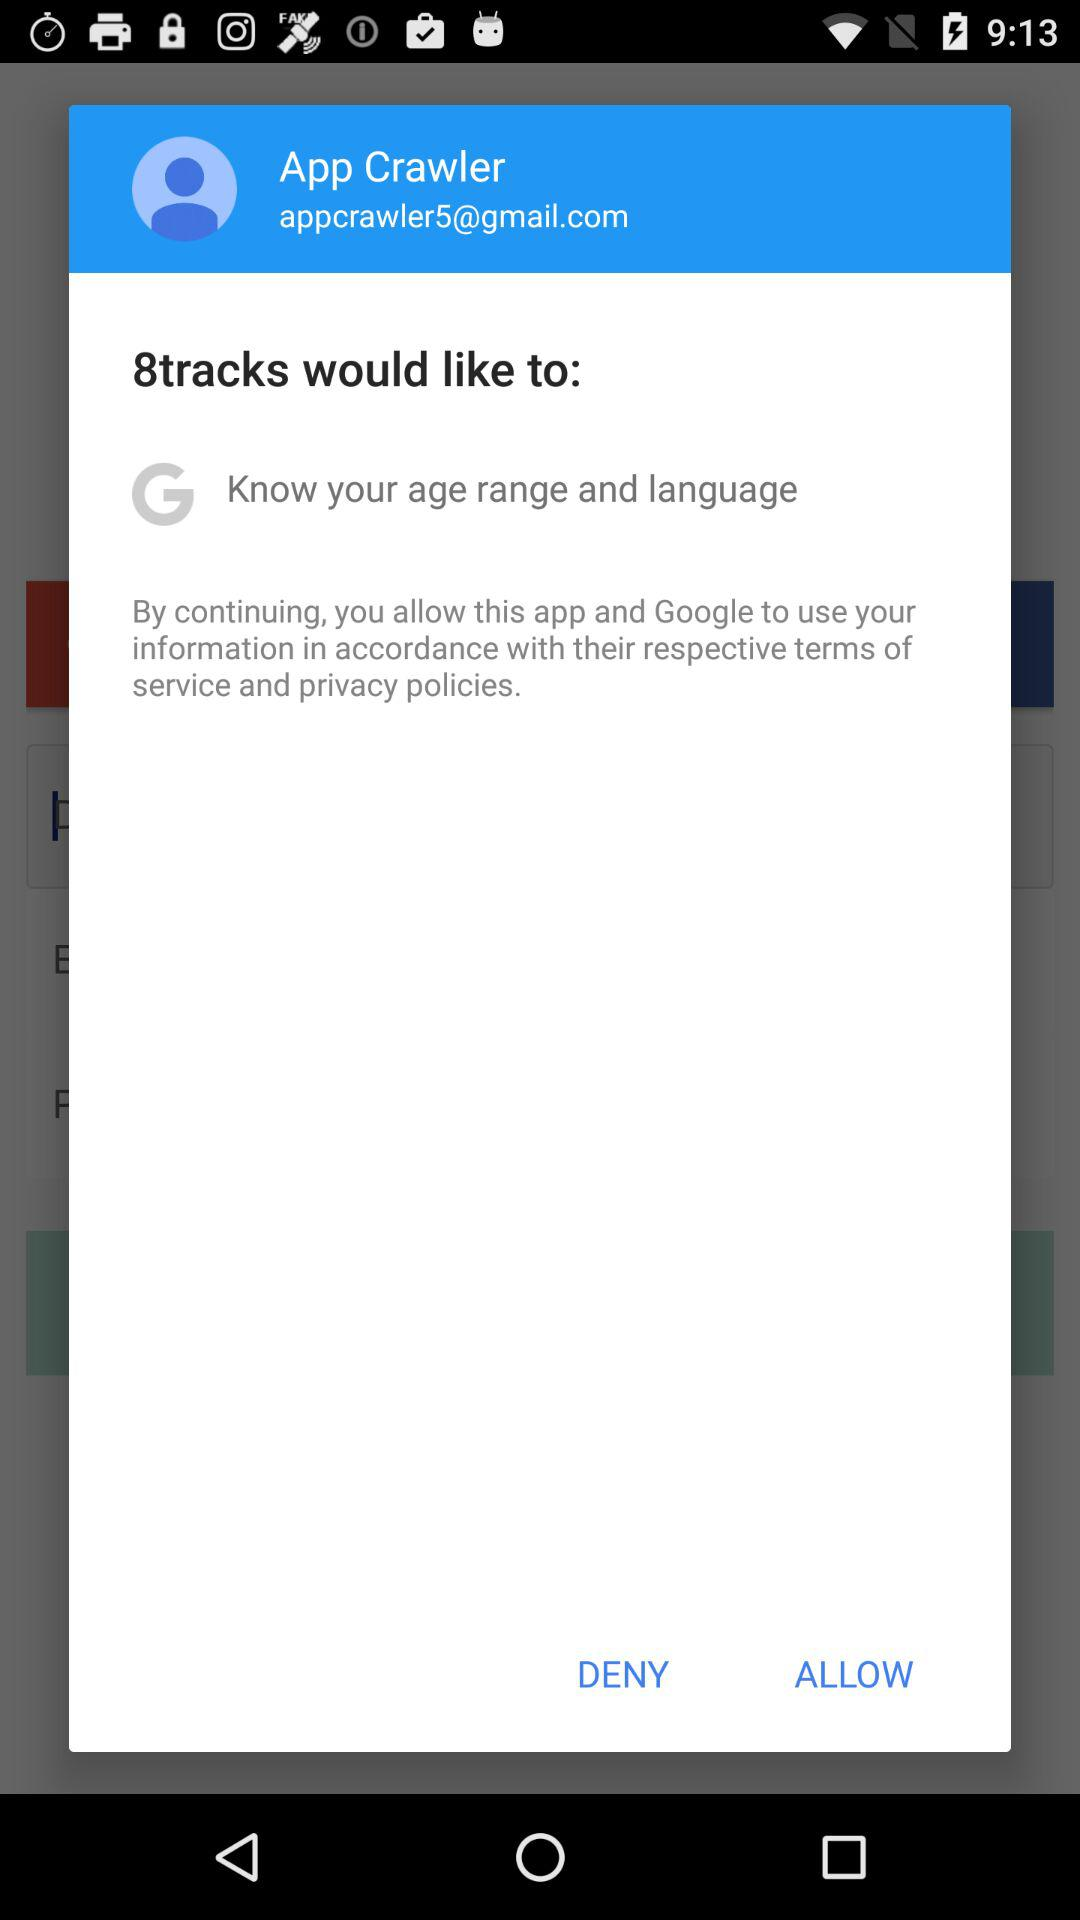What is the email address? The email address is "appcrawler5@gmail.com". 